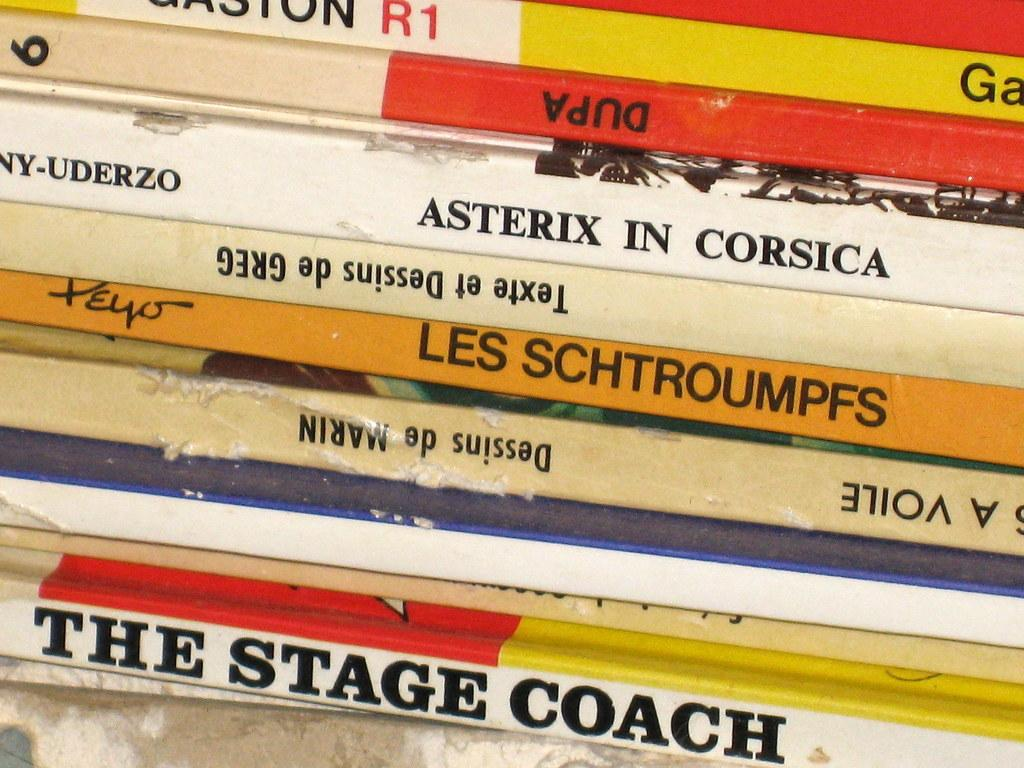What objects are present in the image? There are books in the image. How are the books arranged in the image? The books are placed in a row. What type of fruit can be seen growing on the books in the image? There is no fruit present on the books in the image. What journey are the books taking in the image? The books are not taking a journey in the image; they are simply placed in a row. 